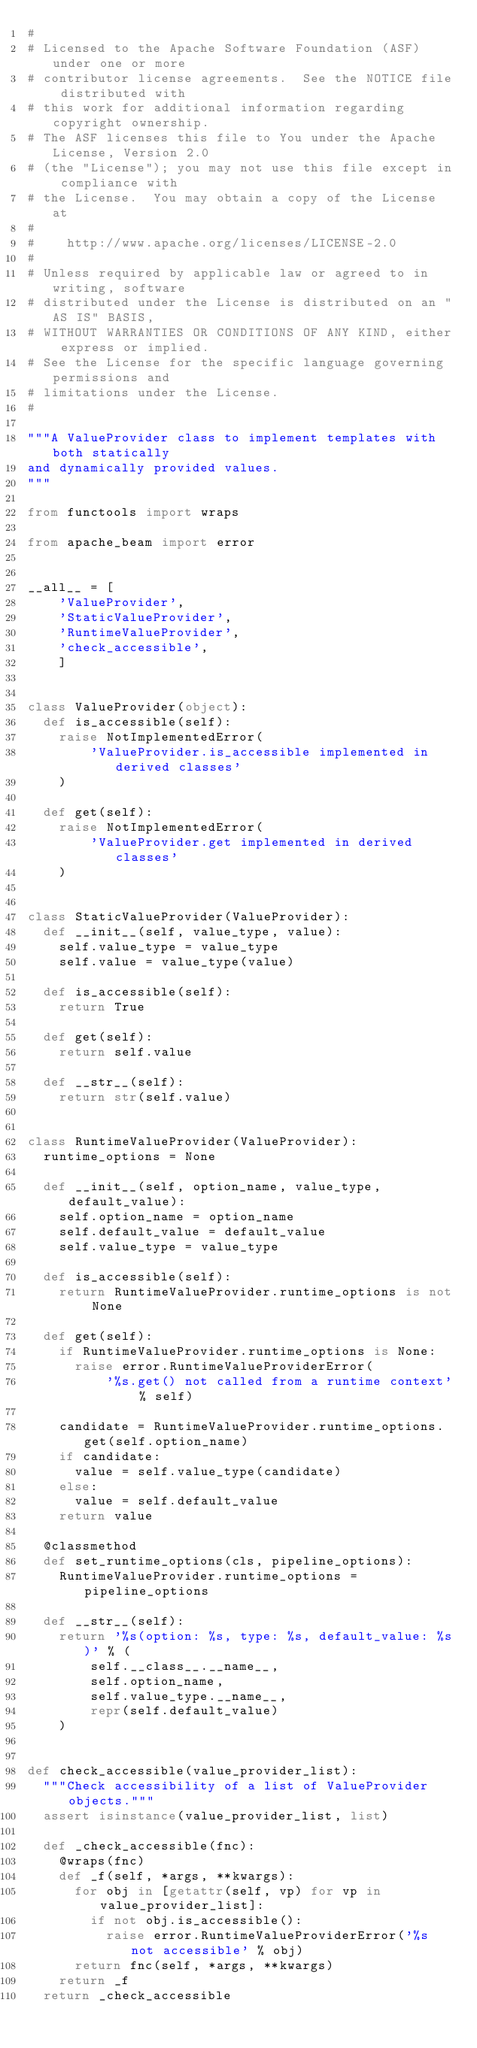Convert code to text. <code><loc_0><loc_0><loc_500><loc_500><_Python_>#
# Licensed to the Apache Software Foundation (ASF) under one or more
# contributor license agreements.  See the NOTICE file distributed with
# this work for additional information regarding copyright ownership.
# The ASF licenses this file to You under the Apache License, Version 2.0
# (the "License"); you may not use this file except in compliance with
# the License.  You may obtain a copy of the License at
#
#    http://www.apache.org/licenses/LICENSE-2.0
#
# Unless required by applicable law or agreed to in writing, software
# distributed under the License is distributed on an "AS IS" BASIS,
# WITHOUT WARRANTIES OR CONDITIONS OF ANY KIND, either express or implied.
# See the License for the specific language governing permissions and
# limitations under the License.
#

"""A ValueProvider class to implement templates with both statically
and dynamically provided values.
"""

from functools import wraps

from apache_beam import error


__all__ = [
    'ValueProvider',
    'StaticValueProvider',
    'RuntimeValueProvider',
    'check_accessible',
    ]


class ValueProvider(object):
  def is_accessible(self):
    raise NotImplementedError(
        'ValueProvider.is_accessible implemented in derived classes'
    )

  def get(self):
    raise NotImplementedError(
        'ValueProvider.get implemented in derived classes'
    )


class StaticValueProvider(ValueProvider):
  def __init__(self, value_type, value):
    self.value_type = value_type
    self.value = value_type(value)

  def is_accessible(self):
    return True

  def get(self):
    return self.value

  def __str__(self):
    return str(self.value)


class RuntimeValueProvider(ValueProvider):
  runtime_options = None

  def __init__(self, option_name, value_type, default_value):
    self.option_name = option_name
    self.default_value = default_value
    self.value_type = value_type

  def is_accessible(self):
    return RuntimeValueProvider.runtime_options is not None

  def get(self):
    if RuntimeValueProvider.runtime_options is None:
      raise error.RuntimeValueProviderError(
          '%s.get() not called from a runtime context' % self)

    candidate = RuntimeValueProvider.runtime_options.get(self.option_name)
    if candidate:
      value = self.value_type(candidate)
    else:
      value = self.default_value
    return value

  @classmethod
  def set_runtime_options(cls, pipeline_options):
    RuntimeValueProvider.runtime_options = pipeline_options

  def __str__(self):
    return '%s(option: %s, type: %s, default_value: %s)' % (
        self.__class__.__name__,
        self.option_name,
        self.value_type.__name__,
        repr(self.default_value)
    )


def check_accessible(value_provider_list):
  """Check accessibility of a list of ValueProvider objects."""
  assert isinstance(value_provider_list, list)

  def _check_accessible(fnc):
    @wraps(fnc)
    def _f(self, *args, **kwargs):
      for obj in [getattr(self, vp) for vp in value_provider_list]:
        if not obj.is_accessible():
          raise error.RuntimeValueProviderError('%s not accessible' % obj)
      return fnc(self, *args, **kwargs)
    return _f
  return _check_accessible
</code> 